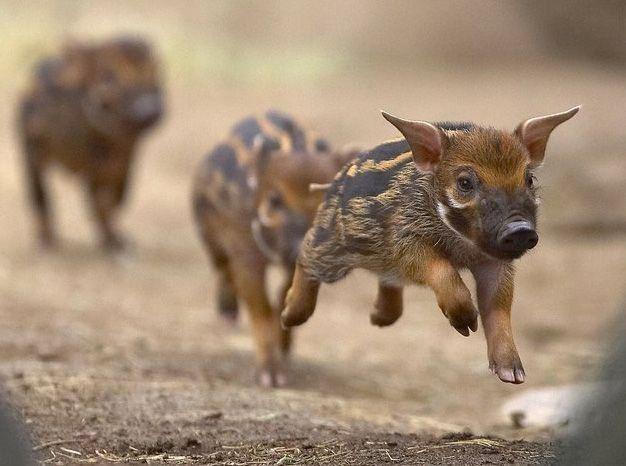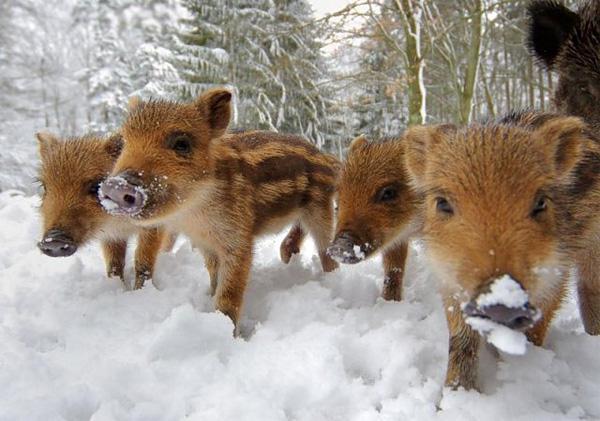The first image is the image on the left, the second image is the image on the right. Considering the images on both sides, is "Both images contain only piglets" valid? Answer yes or no. Yes. 